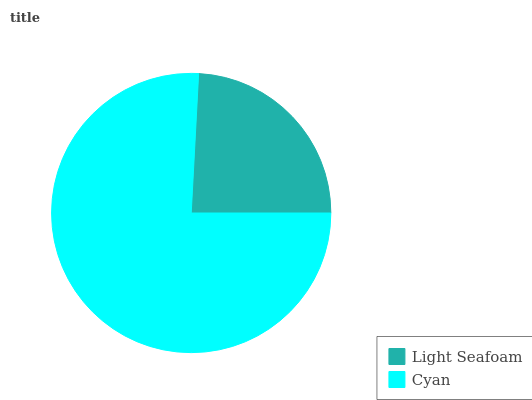Is Light Seafoam the minimum?
Answer yes or no. Yes. Is Cyan the maximum?
Answer yes or no. Yes. Is Cyan the minimum?
Answer yes or no. No. Is Cyan greater than Light Seafoam?
Answer yes or no. Yes. Is Light Seafoam less than Cyan?
Answer yes or no. Yes. Is Light Seafoam greater than Cyan?
Answer yes or no. No. Is Cyan less than Light Seafoam?
Answer yes or no. No. Is Cyan the high median?
Answer yes or no. Yes. Is Light Seafoam the low median?
Answer yes or no. Yes. Is Light Seafoam the high median?
Answer yes or no. No. Is Cyan the low median?
Answer yes or no. No. 